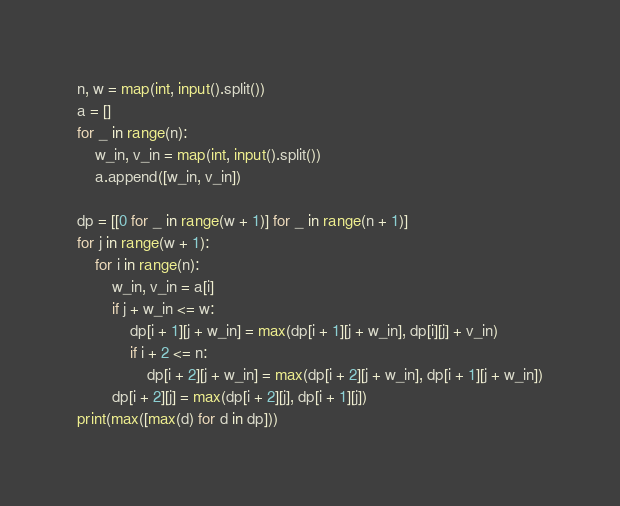<code> <loc_0><loc_0><loc_500><loc_500><_Python_>n, w = map(int, input().split())
a = []
for _ in range(n):
    w_in, v_in = map(int, input().split())
    a.append([w_in, v_in])

dp = [[0 for _ in range(w + 1)] for _ in range(n + 1)]
for j in range(w + 1):
    for i in range(n):
        w_in, v_in = a[i]
        if j + w_in <= w:
            dp[i + 1][j + w_in] = max(dp[i + 1][j + w_in], dp[i][j] + v_in)
            if i + 2 <= n:
                dp[i + 2][j + w_in] = max(dp[i + 2][j + w_in], dp[i + 1][j + w_in])
        dp[i + 2][j] = max(dp[i + 2][j], dp[i + 1][j])
print(max([max(d) for d in dp]))</code> 